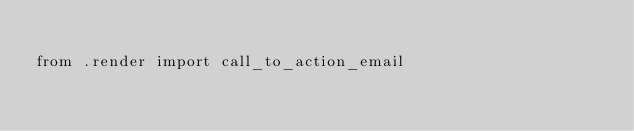<code> <loc_0><loc_0><loc_500><loc_500><_Python_>
from .render import call_to_action_email
</code> 